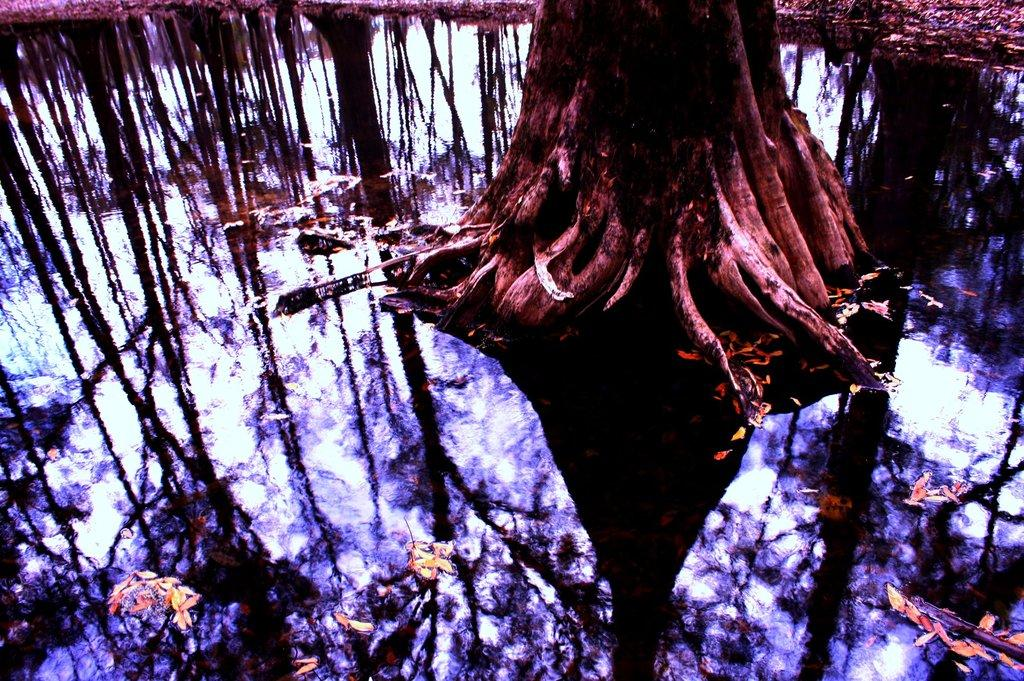What is the main subject of the image? The main subject of the image is a tree trunk. Are there any other trees visible in the image? Yes, there are trees in the image. What type of representative is present in the image? There is no representative present in the image. 